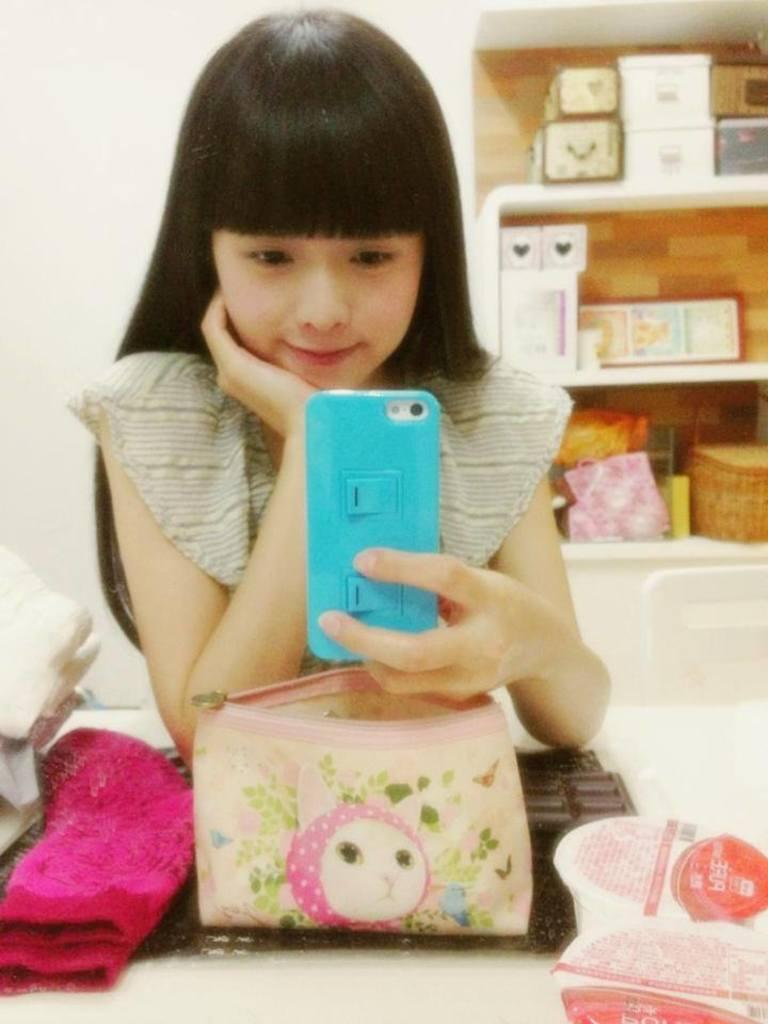Who is present in the image? There is a woman in the image. What is the color of the wall in the image? There is a white color wall in the image. What type of furniture can be seen in the image? There are shelves and a table in the image. What is placed on the table in the image? There is a keyboard, a cloth, and a bag on the table. What type of tail can be seen on the woman in the image? There is no tail visible on the woman in the image. What type of powder is present on the shelves in the image? There is no mention of powder on the shelves in the image. 